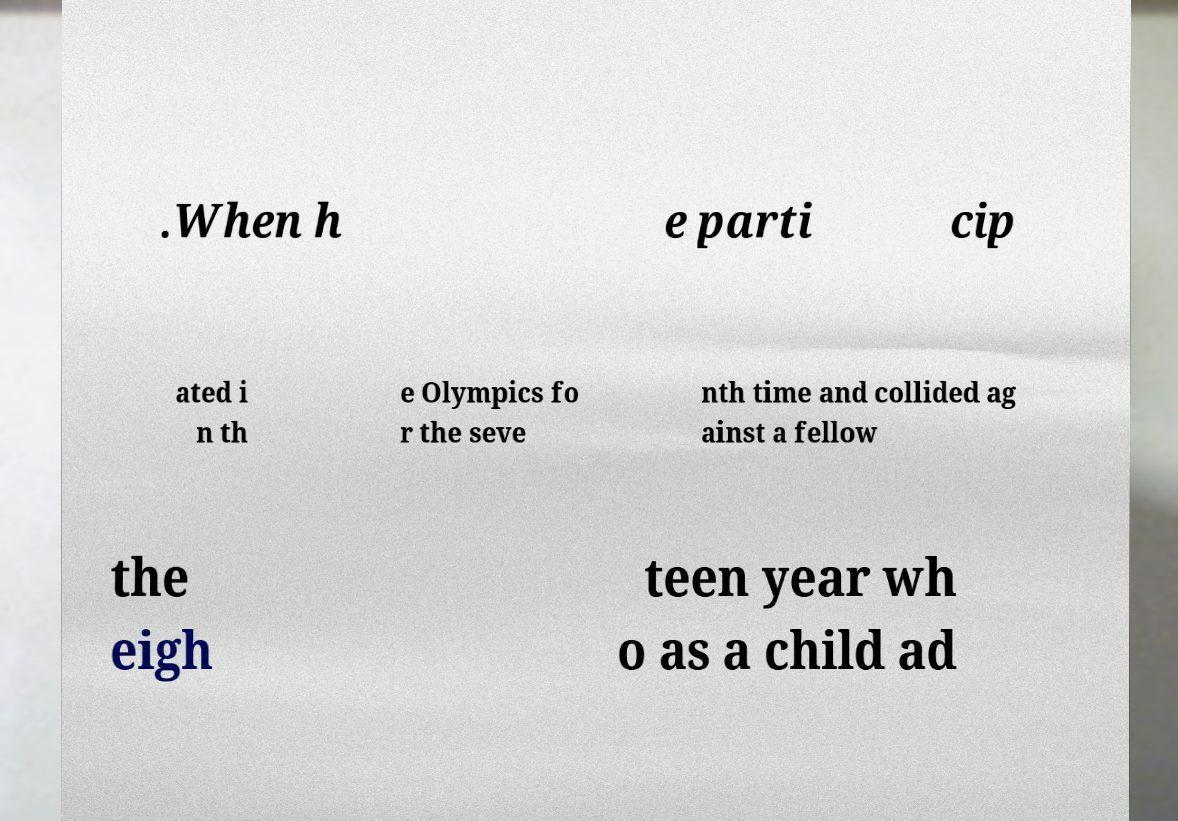Could you assist in decoding the text presented in this image and type it out clearly? .When h e parti cip ated i n th e Olympics fo r the seve nth time and collided ag ainst a fellow the eigh teen year wh o as a child ad 